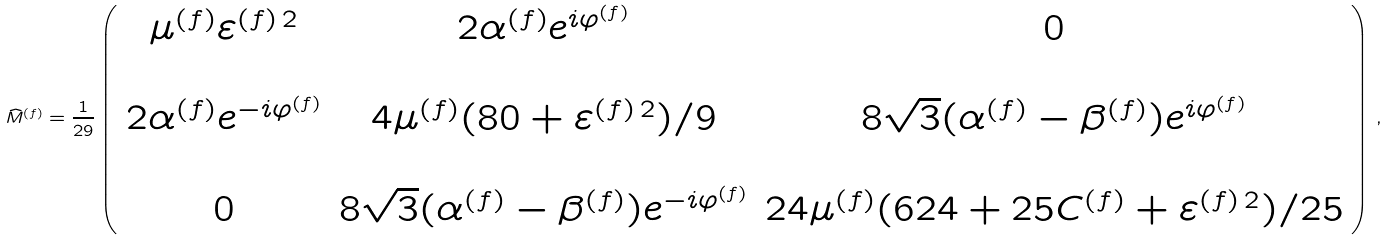Convert formula to latex. <formula><loc_0><loc_0><loc_500><loc_500>\widehat { M } ^ { ( f ) } = \frac { 1 } { 2 9 } \left ( \begin{array} { c c c } \mu ^ { ( f ) } \varepsilon ^ { ( f ) \, 2 } & 2 \alpha ^ { ( f ) } e ^ { i \varphi ^ { ( f ) } } & 0 \\ & & \\ 2 \alpha ^ { ( f ) } e ^ { - i \varphi ^ { ( f ) } } & 4 \mu ^ { ( f ) } ( 8 0 + \varepsilon ^ { ( f ) \, 2 } ) / 9 & 8 \sqrt { 3 } ( \alpha ^ { ( f ) } - \beta ^ { ( f ) } ) e ^ { i \varphi ^ { ( f ) } } \\ & & \\ 0 & 8 \sqrt { 3 } ( \alpha ^ { ( f ) } - \beta ^ { ( f ) } ) e ^ { - i \varphi ^ { ( f ) } } & 2 4 \mu ^ { ( f ) } ( 6 2 4 + 2 5 C ^ { ( f ) } + \varepsilon ^ { ( f ) \, 2 } ) / 2 5 \end{array} \right ) \, ,</formula> 